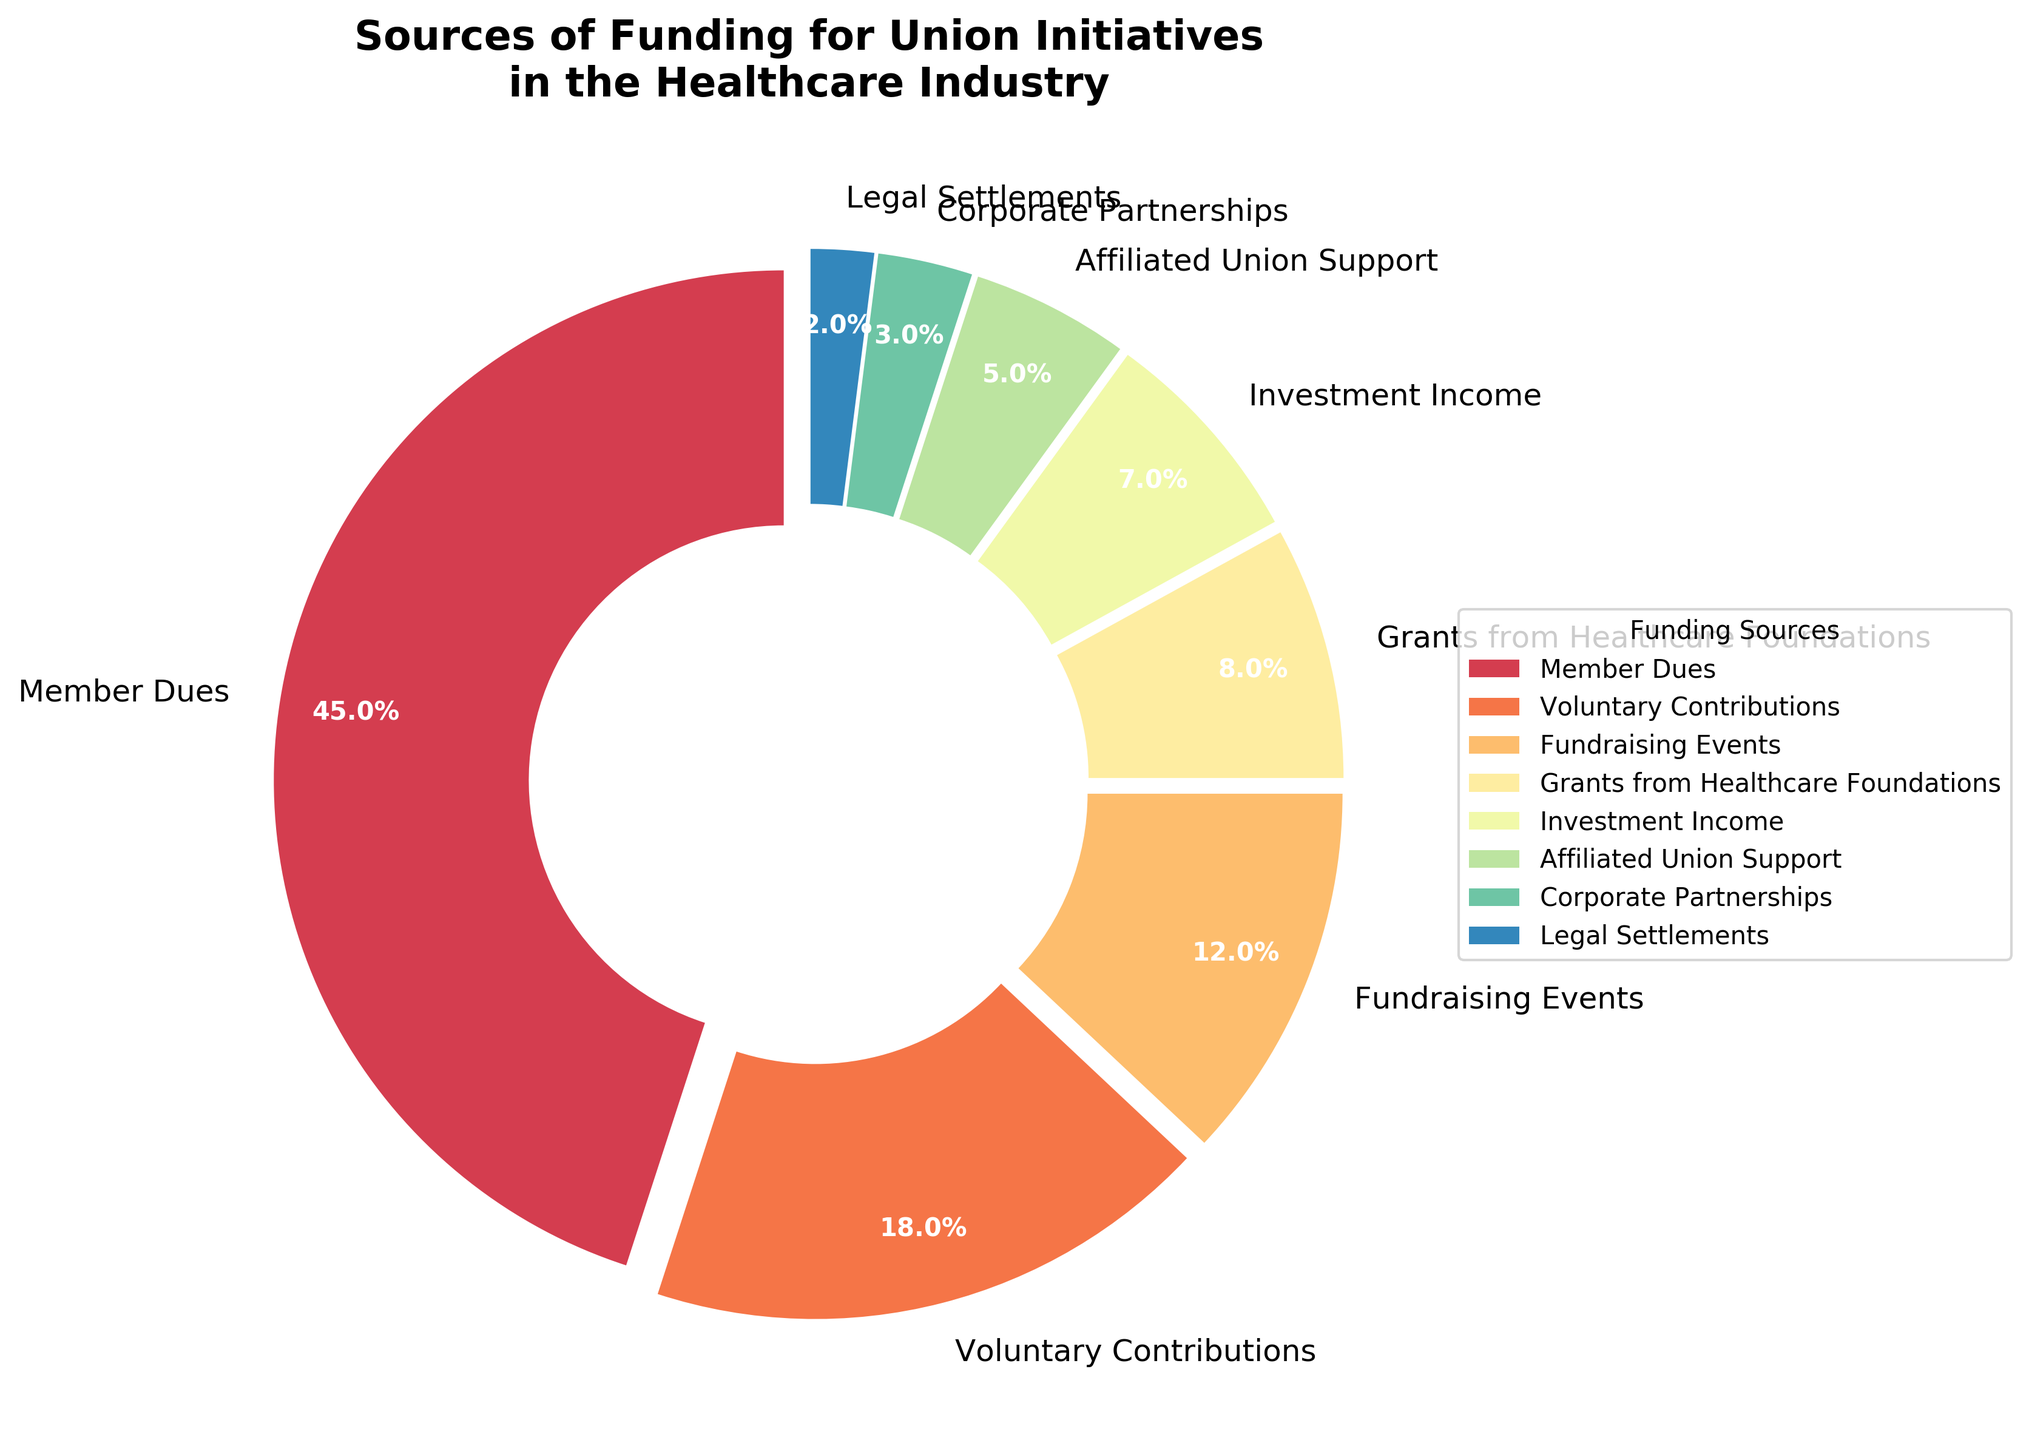What is the largest source of funding for union initiatives? By looking at the pie chart, we can identify the largest wedge which is labeled as "Member Dues" with 45%.
Answer: Member Dues Which funding source contributes the least to the union initiatives? The smallest wedge in the pie chart is labeled "Legal Settlements" with 2%.
Answer: Legal Settlements What is the combined percentage of contributions from Fundraising Events and Corporate Partnerships? Summing up the percentages of "Fundraising Events" (12%) and "Corporate Partnerships" (3%) gives 12 + 3 = 15%.
Answer: 15% How much more does Member Dues contribute relative to Voluntary Contributions? Member Dues contributes 45% and Voluntary Contributions contribute 18%. The difference is 45 - 18 = 27%.
Answer: 27% Arrange the funding sources in descending order of their contributions. Listing the percentages in descending order: Member Dues (45%), Voluntary Contributions (18%), Fundraising Events (12%), Grants from Healthcare Foundations (8%), Investment Income (7%), Affiliated Union Support (5%), Corporate Partnerships (3%), Legal Settlements (2%).
Answer: Member Dues > Voluntary Contributions > Fundraising Events > Grants from Healthcare Foundations > Investment Income > Affiliated Union Support > Corporate Partnerships > Legal Settlements Is the contribution from Investment Income greater than that from Affiliated Union Support? Investment Income contributes 7% while Affiliated Union Support contributes 5%. 7% is greater than 5%.
Answer: Yes Of the sources contributing less than 10%, which one contributes the most? The sources contributing less than 10% are "Grants from Healthcare Foundations" (8%), "Investment Income" (7%), "Affiliated Union Support" (5%), "Corporate Partnerships" (3%), and "Legal Settlements" (2%). The highest among these is "Grants from Healthcare Foundations" with 8%.
Answer: Grants from Healthcare Foundations What is the difference between the percentages of funds from Voluntary Contributions and Fundraising Events? Voluntary Contributions contribute 18% while Fundraising Events contribute 12%. The difference is 18 - 12 = 6%.
Answer: 6% What proportion of the total funding comes from Investments Income and Legal Settlements? Summing the percentages from "Investment Income" (7%) and "Legal Settlements" (2%) gives 7 + 2 = 9%.
Answer: 9% Calculate the combined percentage from sources other than Member Dues and Voluntary Contributions. Summing the percentages of all other sources except "Member Dues" (45%) and "Voluntary Contributions" (18%): Fundraising Events (12%), Grants from Healthcare Foundations (8%), Investment Income (7%), Affiliated Union Support (5%), Corporate Partnerships (3%), and Legal Settlements (2%) results in 12 + 8 + 7 + 5 + 3 + 2 = 37%.
Answer: 37% 